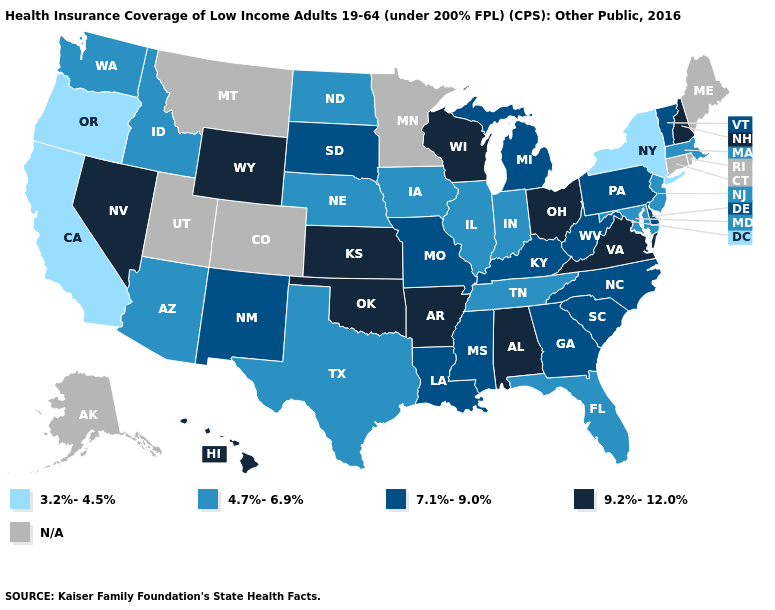Name the states that have a value in the range 7.1%-9.0%?
Be succinct. Delaware, Georgia, Kentucky, Louisiana, Michigan, Mississippi, Missouri, New Mexico, North Carolina, Pennsylvania, South Carolina, South Dakota, Vermont, West Virginia. Name the states that have a value in the range 3.2%-4.5%?
Short answer required. California, New York, Oregon. Among the states that border Connecticut , does Massachusetts have the highest value?
Answer briefly. Yes. Does the first symbol in the legend represent the smallest category?
Keep it brief. Yes. What is the value of Illinois?
Give a very brief answer. 4.7%-6.9%. Is the legend a continuous bar?
Keep it brief. No. What is the value of West Virginia?
Write a very short answer. 7.1%-9.0%. Name the states that have a value in the range N/A?
Write a very short answer. Alaska, Colorado, Connecticut, Maine, Minnesota, Montana, Rhode Island, Utah. Does California have the lowest value in the USA?
Give a very brief answer. Yes. What is the value of Hawaii?
Give a very brief answer. 9.2%-12.0%. Among the states that border Vermont , which have the lowest value?
Short answer required. New York. What is the value of Maryland?
Give a very brief answer. 4.7%-6.9%. Does Delaware have the highest value in the USA?
Quick response, please. No. What is the value of Kentucky?
Concise answer only. 7.1%-9.0%. 